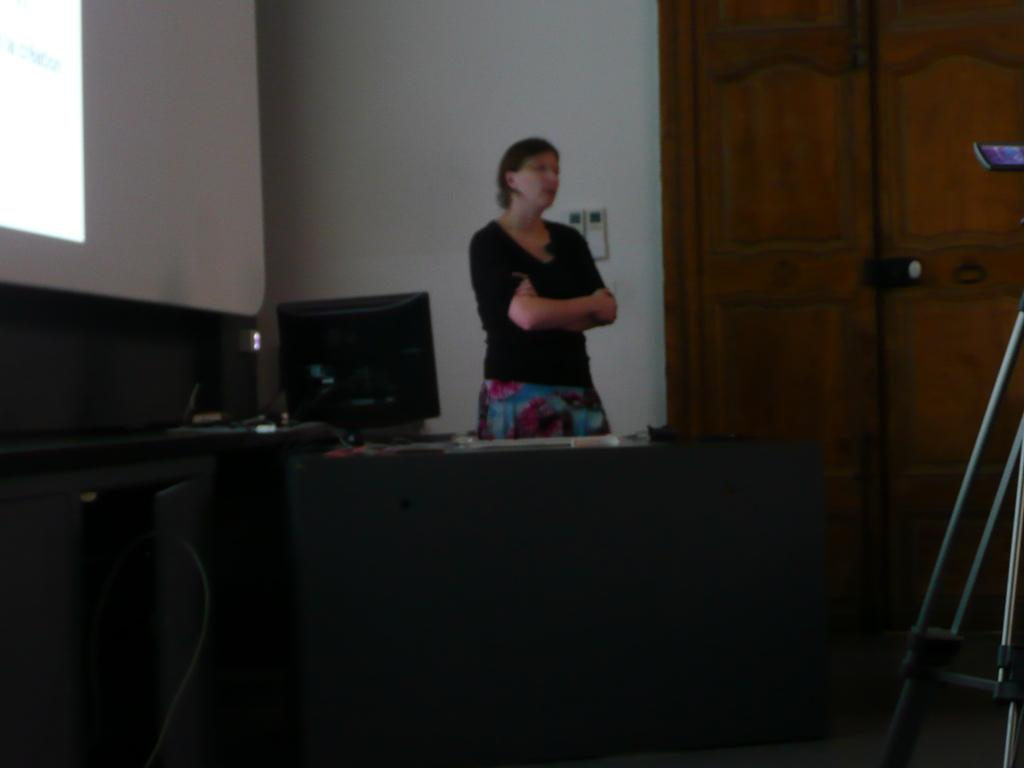What is the main subject of the image? There is a person standing in the image. What electronic device can be seen in the background? There is an electronic device in the background of the image. What other objects are present in the image? There is a monitor and a tripod in the image. What can be seen in the background of the image? There is a door and a wall in the background of the image. What type of rifle is the person holding in the image? There is no rifle present in the image; the person is not holding any weapon. What type of camp can be seen in the background of the image? There is no camp present in the image; the background features a door, a wall, and an electronic device. 